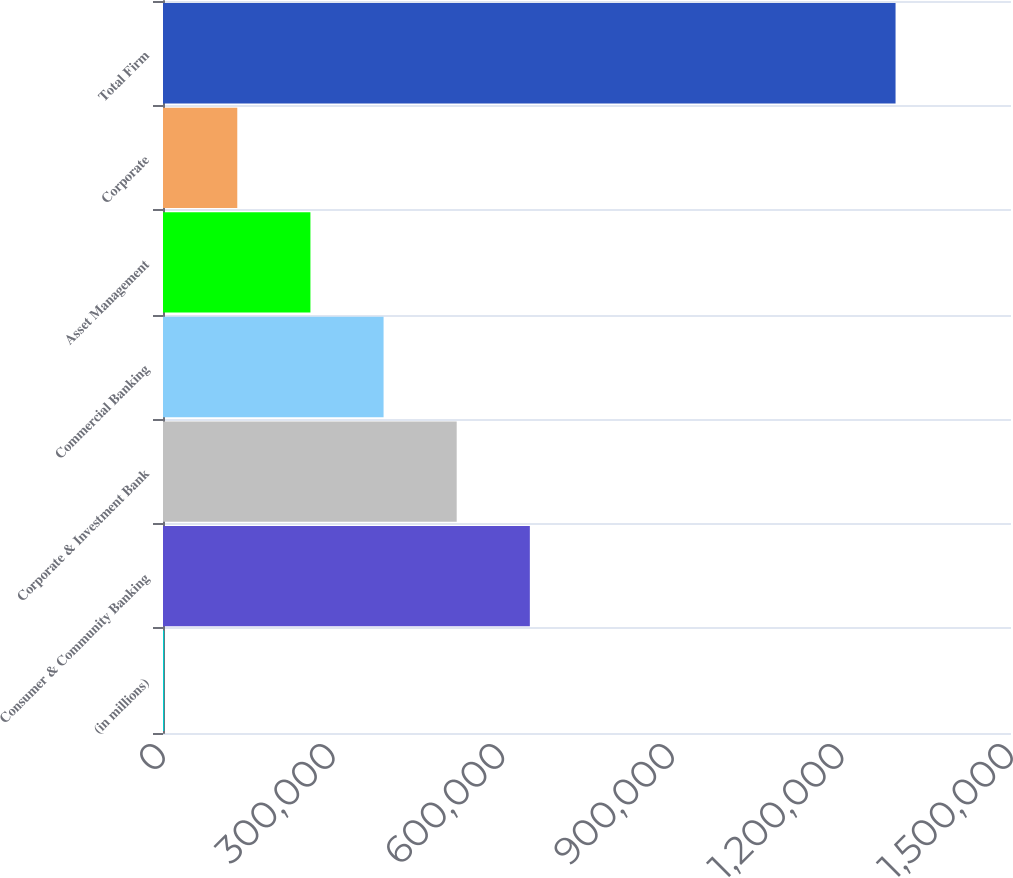<chart> <loc_0><loc_0><loc_500><loc_500><bar_chart><fcel>(in millions)<fcel>Consumer & Community Banking<fcel>Corporate & Investment Bank<fcel>Commercial Banking<fcel>Asset Management<fcel>Corporate<fcel>Total Firm<nl><fcel>2015<fcel>648902<fcel>519524<fcel>390147<fcel>260770<fcel>131392<fcel>1.29579e+06<nl></chart> 